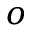Convert formula to latex. <formula><loc_0><loc_0><loc_500><loc_500>o</formula> 